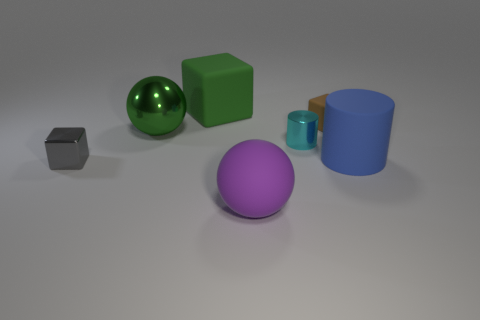Add 1 small yellow matte blocks. How many objects exist? 8 Subtract all large green blocks. How many blocks are left? 2 Subtract all purple spheres. How many spheres are left? 1 Subtract 1 balls. How many balls are left? 1 Subtract all balls. How many objects are left? 5 Subtract all green cubes. How many blue cylinders are left? 1 Subtract all small cyan metallic spheres. Subtract all big rubber cylinders. How many objects are left? 6 Add 1 rubber balls. How many rubber balls are left? 2 Add 6 small objects. How many small objects exist? 9 Subtract 1 green cubes. How many objects are left? 6 